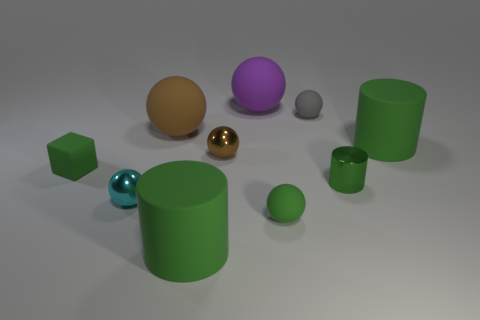Do the large green matte thing that is behind the small block and the small gray thing have the same shape? No, they do not have the same shape. The large green matte object is a cylinder, while the small gray object is a sphere. The cylinder has a long, circular shape with flat ends, typical of objects with a constant diameter along their length. The sphere, on the other hand, is perfectly round in all directions, a shape that is symmetrical from every angle. 